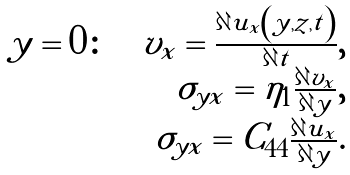<formula> <loc_0><loc_0><loc_500><loc_500>\begin{array} { r } y = 0 \colon \quad v _ { x } = \frac { \partial u _ { x } \left ( y , z , t \right ) } { \partial t } , \\ \sigma _ { y x } = \eta _ { 1 } \frac { \partial v _ { x } } { \partial y } , \\ \sigma _ { y x } = C _ { 4 4 } \frac { \partial u _ { x } } { \partial y } . \end{array}</formula> 